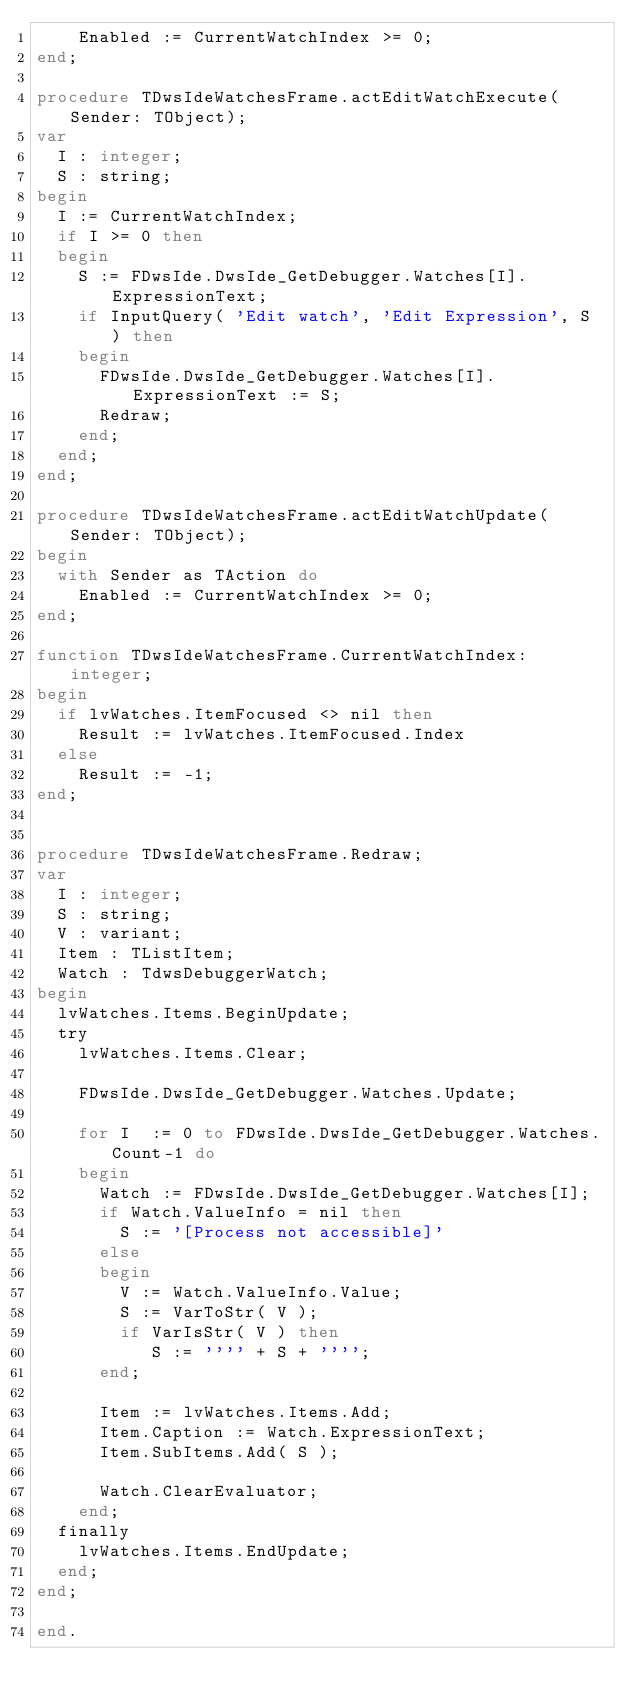Convert code to text. <code><loc_0><loc_0><loc_500><loc_500><_Pascal_>    Enabled := CurrentWatchIndex >= 0;
end;

procedure TDwsIdeWatchesFrame.actEditWatchExecute(Sender: TObject);
var
  I : integer;
  S : string;
begin
  I := CurrentWatchIndex;
  if I >= 0 then
  begin
    S := FDwsIde.DwsIde_GetDebugger.Watches[I].ExpressionText;
    if InputQuery( 'Edit watch', 'Edit Expression', S ) then
    begin
      FDwsIde.DwsIde_GetDebugger.Watches[I].ExpressionText := S;
      Redraw;
    end;
  end;
end;

procedure TDwsIdeWatchesFrame.actEditWatchUpdate(Sender: TObject);
begin
  with Sender as TAction do
    Enabled := CurrentWatchIndex >= 0;
end;

function TDwsIdeWatchesFrame.CurrentWatchIndex: integer;
begin
  if lvWatches.ItemFocused <> nil then
    Result := lvWatches.ItemFocused.Index
  else
    Result := -1;
end;


procedure TDwsIdeWatchesFrame.Redraw;
var
  I : integer;
  S : string;
  V : variant;
  Item : TListItem;
  Watch : TdwsDebuggerWatch;
begin
  lvWatches.Items.BeginUpdate;
  try
    lvWatches.Items.Clear;

    FDwsIde.DwsIde_GetDebugger.Watches.Update;

    for I  := 0 to FDwsIde.DwsIde_GetDebugger.Watches.Count-1 do
    begin
      Watch := FDwsIde.DwsIde_GetDebugger.Watches[I];
      if Watch.ValueInfo = nil then
        S := '[Process not accessible]'
      else
      begin
        V := Watch.ValueInfo.Value;
        S := VarToStr( V );
        if VarIsStr( V ) then
           S := '''' + S + '''';
      end;

      Item := lvWatches.Items.Add;
      Item.Caption := Watch.ExpressionText;
      Item.SubItems.Add( S );

      Watch.ClearEvaluator;
    end;
  finally
    lvWatches.Items.EndUpdate;
  end;
end;

end.
</code> 